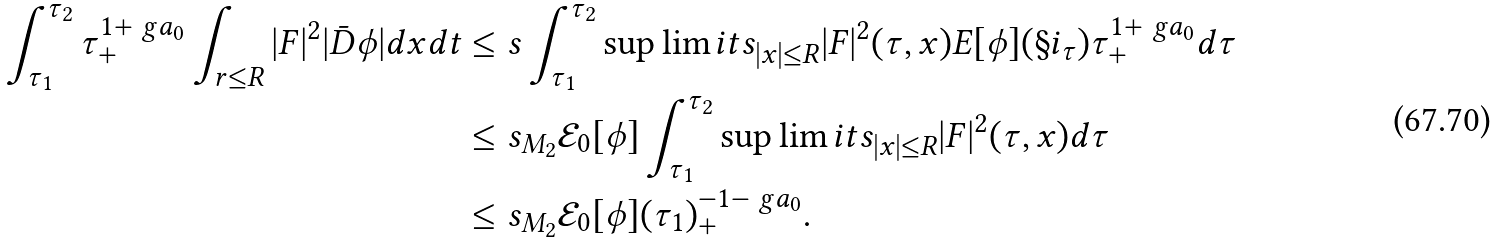<formula> <loc_0><loc_0><loc_500><loc_500>\int _ { \tau _ { 1 } } ^ { \tau _ { 2 } } \tau _ { + } ^ { 1 + \ g a _ { 0 } } \int _ { r \leq R } | F | ^ { 2 } | \bar { D } \phi | d x d t & \leq s \int _ { \tau _ { 1 } } ^ { \tau _ { 2 } } \sup \lim i t s _ { | x | \leq R } | F | ^ { 2 } ( \tau , x ) E [ \phi ] ( \S i _ { \tau } ) \tau _ { + } ^ { 1 + \ g a _ { 0 } } d \tau \\ & \leq s _ { M _ { 2 } } \mathcal { E } _ { 0 } [ \phi ] \int _ { \tau _ { 1 } } ^ { \tau _ { 2 } } \sup \lim i t s _ { | x | \leq R } | F | ^ { 2 } ( \tau , x ) d \tau \\ & \leq s _ { M _ { 2 } } \mathcal { E } _ { 0 } [ \phi ] ( \tau _ { 1 } ) _ { + } ^ { - 1 - \ g a _ { 0 } } .</formula> 